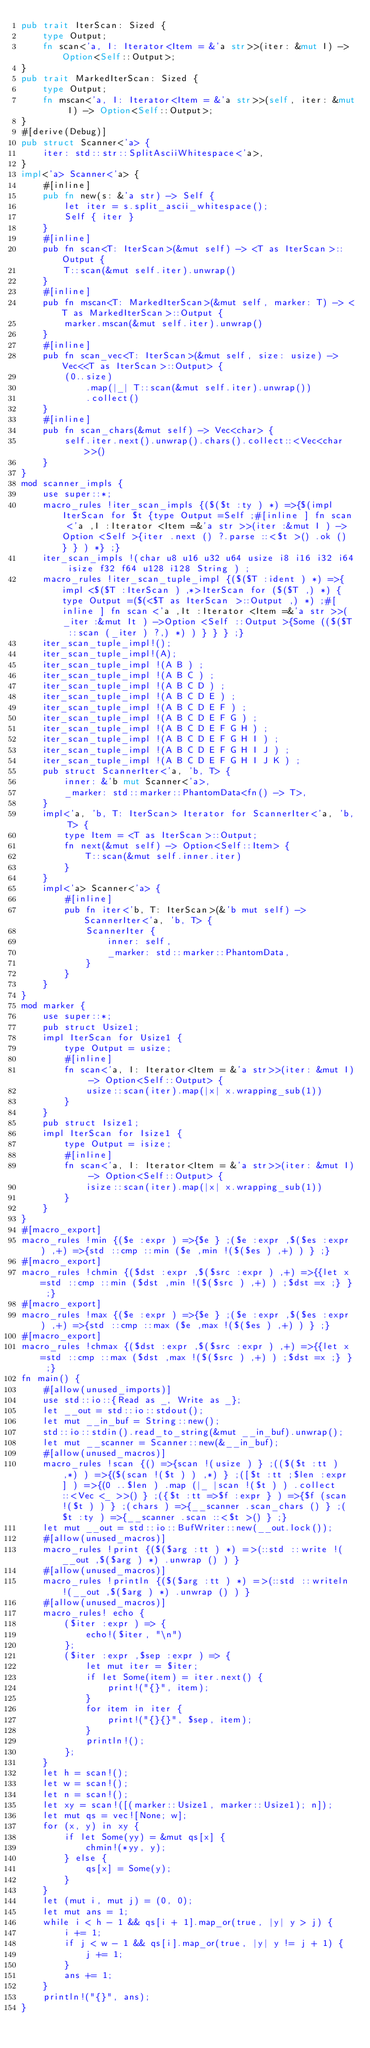<code> <loc_0><loc_0><loc_500><loc_500><_Rust_>pub trait IterScan: Sized {
    type Output;
    fn scan<'a, I: Iterator<Item = &'a str>>(iter: &mut I) -> Option<Self::Output>;
}
pub trait MarkedIterScan: Sized {
    type Output;
    fn mscan<'a, I: Iterator<Item = &'a str>>(self, iter: &mut I) -> Option<Self::Output>;
}
#[derive(Debug)]
pub struct Scanner<'a> {
    iter: std::str::SplitAsciiWhitespace<'a>,
}
impl<'a> Scanner<'a> {
    #[inline]
    pub fn new(s: &'a str) -> Self {
        let iter = s.split_ascii_whitespace();
        Self { iter }
    }
    #[inline]
    pub fn scan<T: IterScan>(&mut self) -> <T as IterScan>::Output {
        T::scan(&mut self.iter).unwrap()
    }
    #[inline]
    pub fn mscan<T: MarkedIterScan>(&mut self, marker: T) -> <T as MarkedIterScan>::Output {
        marker.mscan(&mut self.iter).unwrap()
    }
    #[inline]
    pub fn scan_vec<T: IterScan>(&mut self, size: usize) -> Vec<<T as IterScan>::Output> {
        (0..size)
            .map(|_| T::scan(&mut self.iter).unwrap())
            .collect()
    }
    #[inline]
    pub fn scan_chars(&mut self) -> Vec<char> {
        self.iter.next().unwrap().chars().collect::<Vec<char>>()
    }
}
mod scanner_impls {
    use super::*;
    macro_rules !iter_scan_impls {($($t :ty ) *) =>{$(impl IterScan for $t {type Output =Self ;#[inline ] fn scan <'a ,I :Iterator <Item =&'a str >>(iter :&mut I ) ->Option <Self >{iter .next () ?.parse ::<$t >() .ok () } } ) *} ;}
    iter_scan_impls !(char u8 u16 u32 u64 usize i8 i16 i32 i64 isize f32 f64 u128 i128 String ) ;
    macro_rules !iter_scan_tuple_impl {($($T :ident ) *) =>{impl <$($T :IterScan ) ,*>IterScan for ($($T ,) *) {type Output =($(<$T as IterScan >::Output ,) *) ;#[inline ] fn scan <'a ,It :Iterator <Item =&'a str >>(_iter :&mut It ) ->Option <Self ::Output >{Some (($($T ::scan (_iter ) ?,) *) ) } } } ;}
    iter_scan_tuple_impl!();
    iter_scan_tuple_impl!(A);
    iter_scan_tuple_impl !(A B ) ;
    iter_scan_tuple_impl !(A B C ) ;
    iter_scan_tuple_impl !(A B C D ) ;
    iter_scan_tuple_impl !(A B C D E ) ;
    iter_scan_tuple_impl !(A B C D E F ) ;
    iter_scan_tuple_impl !(A B C D E F G ) ;
    iter_scan_tuple_impl !(A B C D E F G H ) ;
    iter_scan_tuple_impl !(A B C D E F G H I ) ;
    iter_scan_tuple_impl !(A B C D E F G H I J ) ;
    iter_scan_tuple_impl !(A B C D E F G H I J K ) ;
    pub struct ScannerIter<'a, 'b, T> {
        inner: &'b mut Scanner<'a>,
        _marker: std::marker::PhantomData<fn() -> T>,
    }
    impl<'a, 'b, T: IterScan> Iterator for ScannerIter<'a, 'b, T> {
        type Item = <T as IterScan>::Output;
        fn next(&mut self) -> Option<Self::Item> {
            T::scan(&mut self.inner.iter)
        }
    }
    impl<'a> Scanner<'a> {
        #[inline]
        pub fn iter<'b, T: IterScan>(&'b mut self) -> ScannerIter<'a, 'b, T> {
            ScannerIter {
                inner: self,
                _marker: std::marker::PhantomData,
            }
        }
    }
}
mod marker {
    use super::*;
    pub struct Usize1;
    impl IterScan for Usize1 {
        type Output = usize;
        #[inline]
        fn scan<'a, I: Iterator<Item = &'a str>>(iter: &mut I) -> Option<Self::Output> {
            usize::scan(iter).map(|x| x.wrapping_sub(1))
        }
    }
    pub struct Isize1;
    impl IterScan for Isize1 {
        type Output = isize;
        #[inline]
        fn scan<'a, I: Iterator<Item = &'a str>>(iter: &mut I) -> Option<Self::Output> {
            isize::scan(iter).map(|x| x.wrapping_sub(1))
        }
    }
}
#[macro_export]
macro_rules !min {($e :expr ) =>{$e } ;($e :expr ,$($es :expr ) ,+) =>{std ::cmp ::min ($e ,min !($($es ) ,+) ) } ;}
#[macro_export]
macro_rules !chmin {($dst :expr ,$($src :expr ) ,+) =>{{let x =std ::cmp ::min ($dst ,min !($($src ) ,+) ) ;$dst =x ;} } ;}
#[macro_export]
macro_rules !max {($e :expr ) =>{$e } ;($e :expr ,$($es :expr ) ,+) =>{std ::cmp ::max ($e ,max !($($es ) ,+) ) } ;}
#[macro_export]
macro_rules !chmax {($dst :expr ,$($src :expr ) ,+) =>{{let x =std ::cmp ::max ($dst ,max !($($src ) ,+) ) ;$dst =x ;} } ;}
fn main() {
    #[allow(unused_imports)]
    use std::io::{Read as _, Write as _};
    let __out = std::io::stdout();
    let mut __in_buf = String::new();
    std::io::stdin().read_to_string(&mut __in_buf).unwrap();
    let mut __scanner = Scanner::new(&__in_buf);
    #[allow(unused_macros)]
    macro_rules !scan {() =>{scan !(usize ) } ;(($($t :tt ) ,*) ) =>{($(scan !($t ) ) ,*) } ;([$t :tt ;$len :expr ] ) =>{(0 ..$len ) .map (|_ |scan !($t ) ) .collect ::<Vec <_ >>() } ;({$t :tt =>$f :expr } ) =>{$f (scan !($t ) ) } ;(chars ) =>{__scanner .scan_chars () } ;($t :ty ) =>{__scanner .scan ::<$t >() } ;}
    let mut __out = std::io::BufWriter::new(__out.lock());
    #[allow(unused_macros)]
    macro_rules !print {($($arg :tt ) *) =>(::std ::write !(__out ,$($arg ) *) .unwrap () ) }
    #[allow(unused_macros)]
    macro_rules !println {($($arg :tt ) *) =>(::std ::writeln !(__out ,$($arg ) *) .unwrap () ) }
    #[allow(unused_macros)]
    macro_rules! echo {
        ($iter :expr ) => {
            echo!($iter, "\n")
        };
        ($iter :expr ,$sep :expr ) => {
            let mut iter = $iter;
            if let Some(item) = iter.next() {
                print!("{}", item);
            }
            for item in iter {
                print!("{}{}", $sep, item);
            }
            println!();
        };
    }
    let h = scan!();
    let w = scan!();
    let n = scan!();
    let xy = scan!([(marker::Usize1, marker::Usize1); n]);
    let mut qs = vec![None; w];
    for (x, y) in xy {
        if let Some(yy) = &mut qs[x] {
            chmin!(*yy, y);
        } else {
            qs[x] = Some(y);
        }
    }
    let (mut i, mut j) = (0, 0);
    let mut ans = 1;
    while i < h - 1 && qs[i + 1].map_or(true, |y| y > j) {
        i += 1;
        if j < w - 1 && qs[i].map_or(true, |y| y != j + 1) {
            j += 1;
        }
        ans += 1;
    }
    println!("{}", ans);
}</code> 